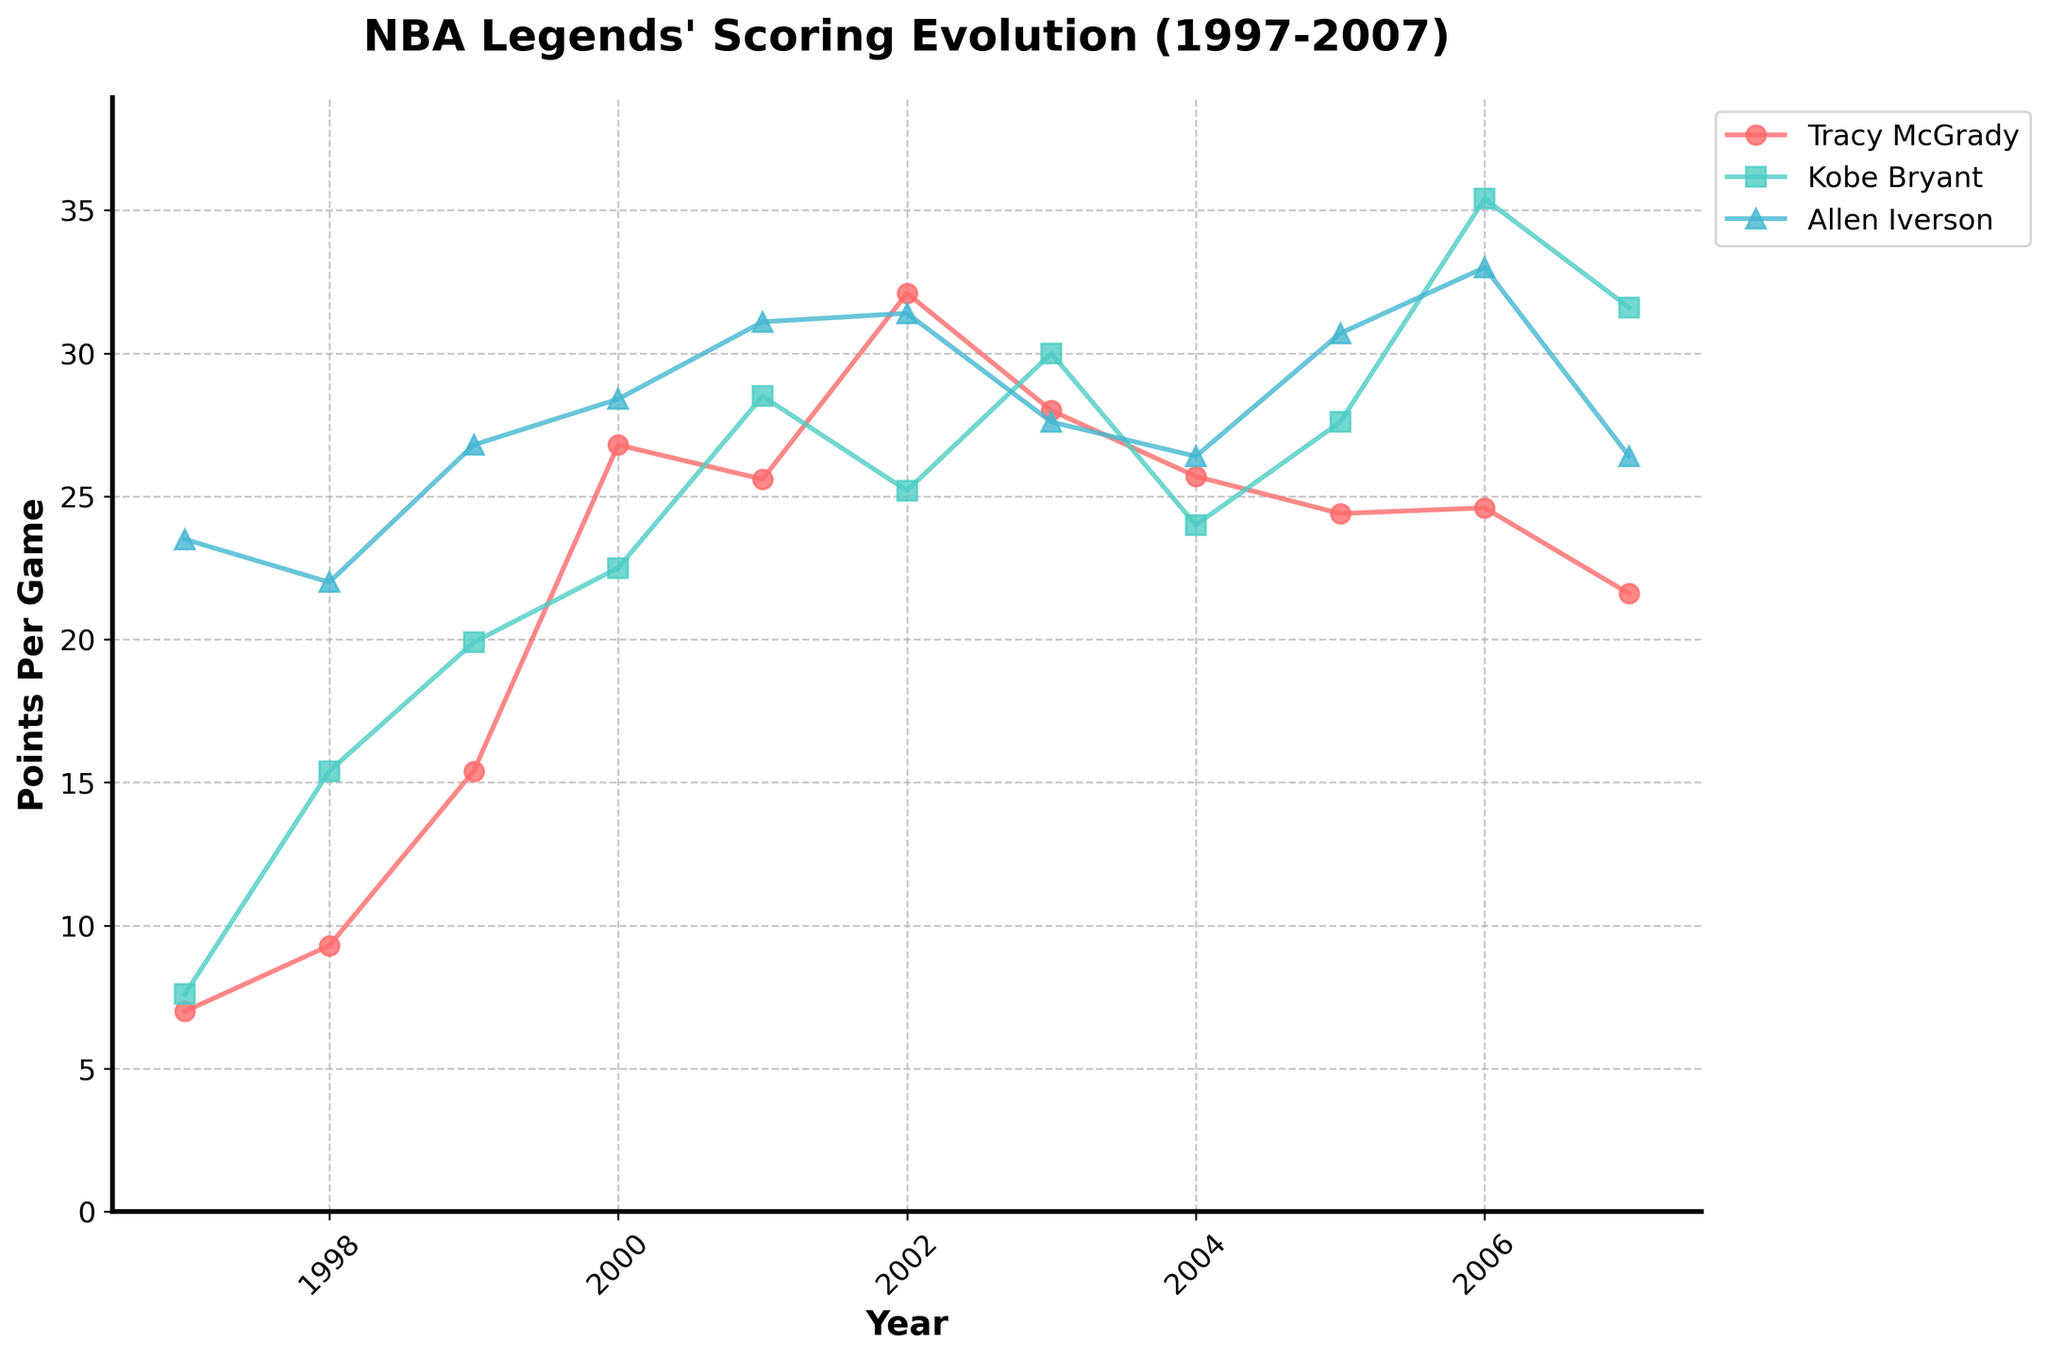Which player averaged the highest points per game in 2002? The plot shows each player's points per game for each year. By identifying the highest point in 2002 across all players, we see that Tracy McGrady's average was the highest with 32.1 points per game.
Answer: Tracy McGrady How did Tracy McGrady's points per game trend from 1997 to 2002? Observing the line representing Tracy McGrady, we see a consistent upward trend in his points per game from 1997 to 2002, peaking at 32.1 points per game in 2002.
Answer: Increased Which player had the biggest year-to-year increase in points per game between consecutive years? By comparing the year-to-year differences of each player's points per game, we find that Tracy McGrady had a significant jump from 1999 to 2000, from 15.4 to 26.8 points per game, an increase of 11.4 points.
Answer: Tracy McGrady Compare Kobe Bryant’s and Tracy McGrady’s points per game in their best scoring year. Who had the higher value, and by how much? Kobe Bryant's best scoring year was 2006 with 35.4 points per game, while Tracy McGrady's best was 2002 with 32.1 points per game. The difference is 35.4 - 32.1 = 3.3 points per game.
Answer: Kobe Bryant, by 3.3 points During 1999, who had the highest assists per game among the three players? By examining the assists per game for 1999, we see Allen Iverson with 4.6 assists per game, which is higher than Tracy McGrady's and Kobe Bryant's values.
Answer: Allen Iverson What was the range of Tracy McGrady's points per game during his peak years (2000 to 2003)? From 2000 to 2003, Tracy McGrady's points per game ranged from a minimum of 25.6 (in 2001) to a maximum of 32.1 (in 2002).
Answer: 25.6 to 32.1 Did any player have a consistent increase in points per game from 1997 to 2007 without any dips? By following each player's trend, no player consistently increased their points per game every year without experiencing dips or plateaus during the period.
Answer: No How do Tracy McGrady's assists per game in 2004 compare to Kobe Bryant's in the same year? Tracy McGrady averaged 6.2 assists per game in 2004, while Kobe Bryant averaged 5.1 assists per game, indicating Tracy McGrady had higher assists.
Answer: Tracy McGrady had more assists Between the years 2005 and 2006, which player showed a decline in points per game? Analyzing the trends for 2005 and 2006, Kobe Bryant experienced a decline in points per game from 27.6 to 24.0.
Answer: Kobe Bryant 